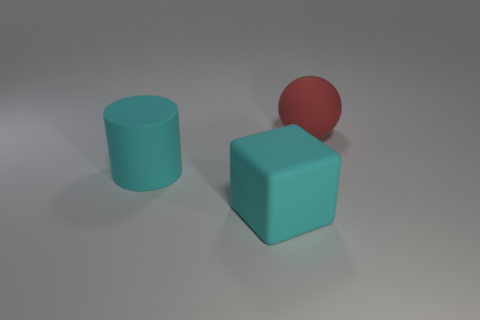What is the material of the block that is the same size as the red thing?
Your answer should be compact. Rubber. Is there a big block made of the same material as the red sphere?
Your response must be concise. Yes. There is a matte object left of the cyan thing to the right of the big thing on the left side of the big block; what is its shape?
Your answer should be compact. Cylinder. There is a rubber cylinder; is it the same size as the thing that is on the right side of the big cyan cube?
Your answer should be very brief. Yes. There is a large thing that is to the left of the red object and behind the big matte block; what is its shape?
Make the answer very short. Cylinder. How many big things are either cylinders or blocks?
Keep it short and to the point. 2. Is the number of big red balls that are left of the large cyan matte block the same as the number of cylinders in front of the large rubber ball?
Your answer should be very brief. No. How many other things are there of the same color as the big block?
Offer a terse response. 1. Is the number of big objects on the right side of the big red object the same as the number of cyan rubber objects?
Keep it short and to the point. No. Do the red ball and the cylinder have the same size?
Keep it short and to the point. Yes. 